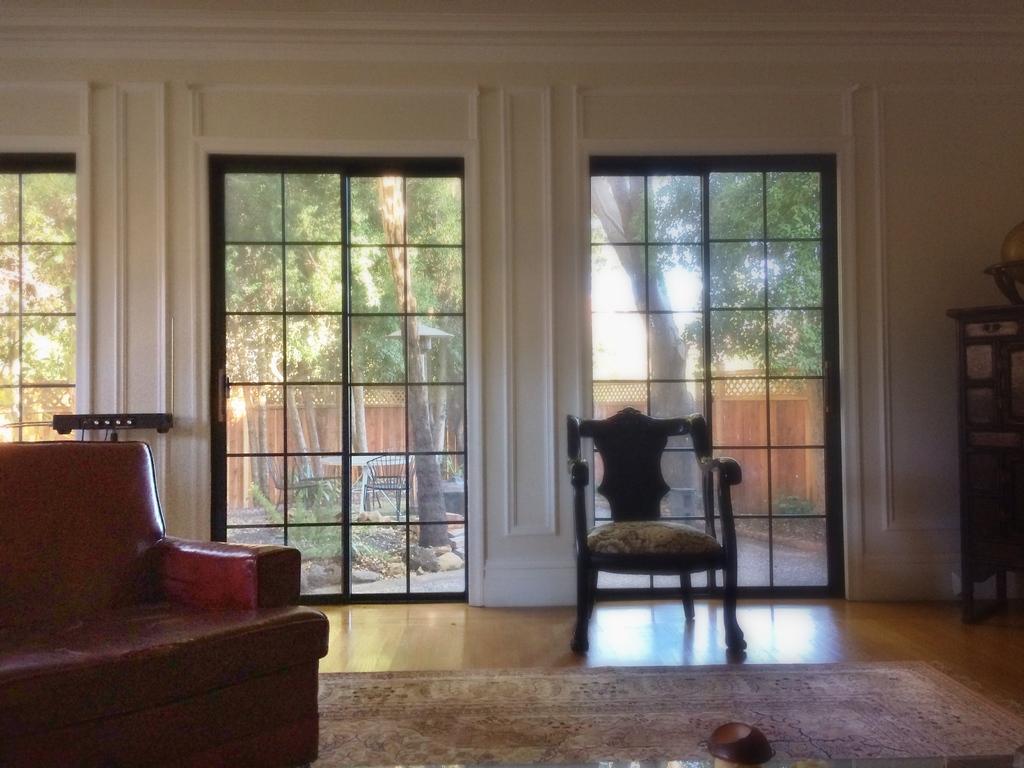Describe this image in one or two sentences. In this image i can see a couch, background i can see a chair, window, plant and sky. 